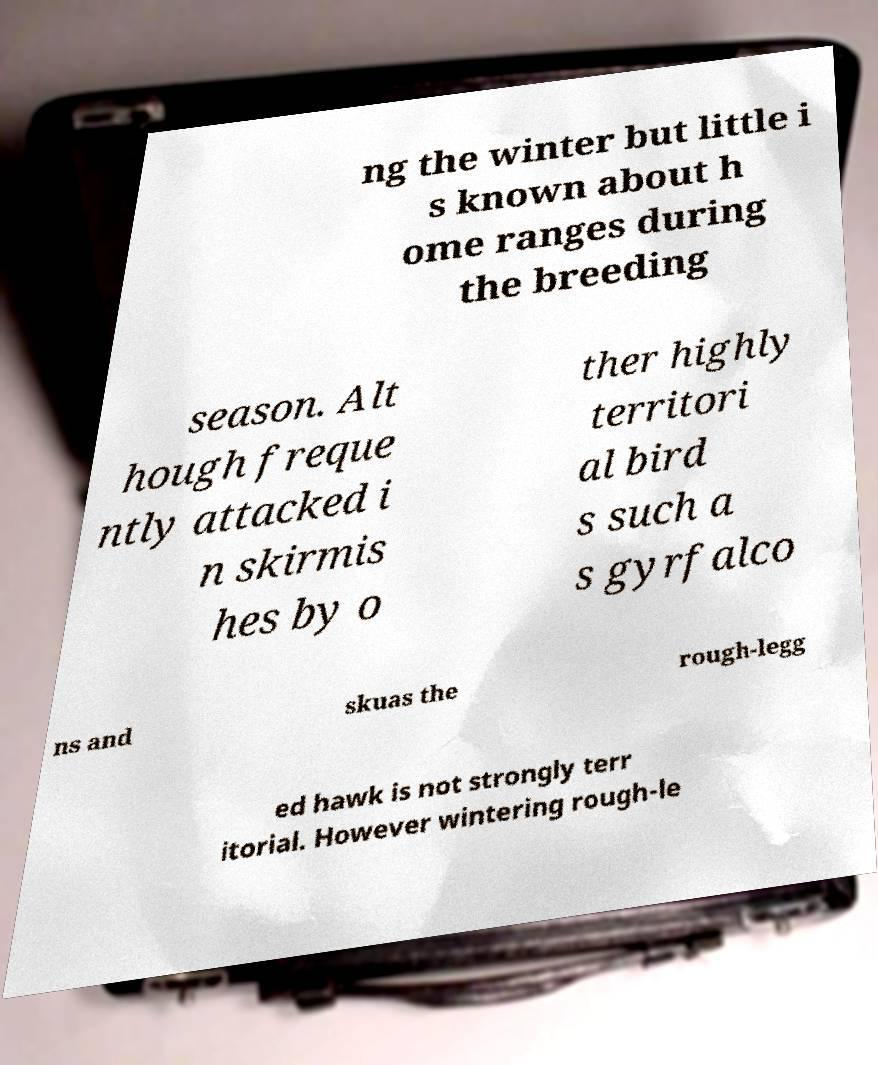Please identify and transcribe the text found in this image. ng the winter but little i s known about h ome ranges during the breeding season. Alt hough freque ntly attacked i n skirmis hes by o ther highly territori al bird s such a s gyrfalco ns and skuas the rough-legg ed hawk is not strongly terr itorial. However wintering rough-le 